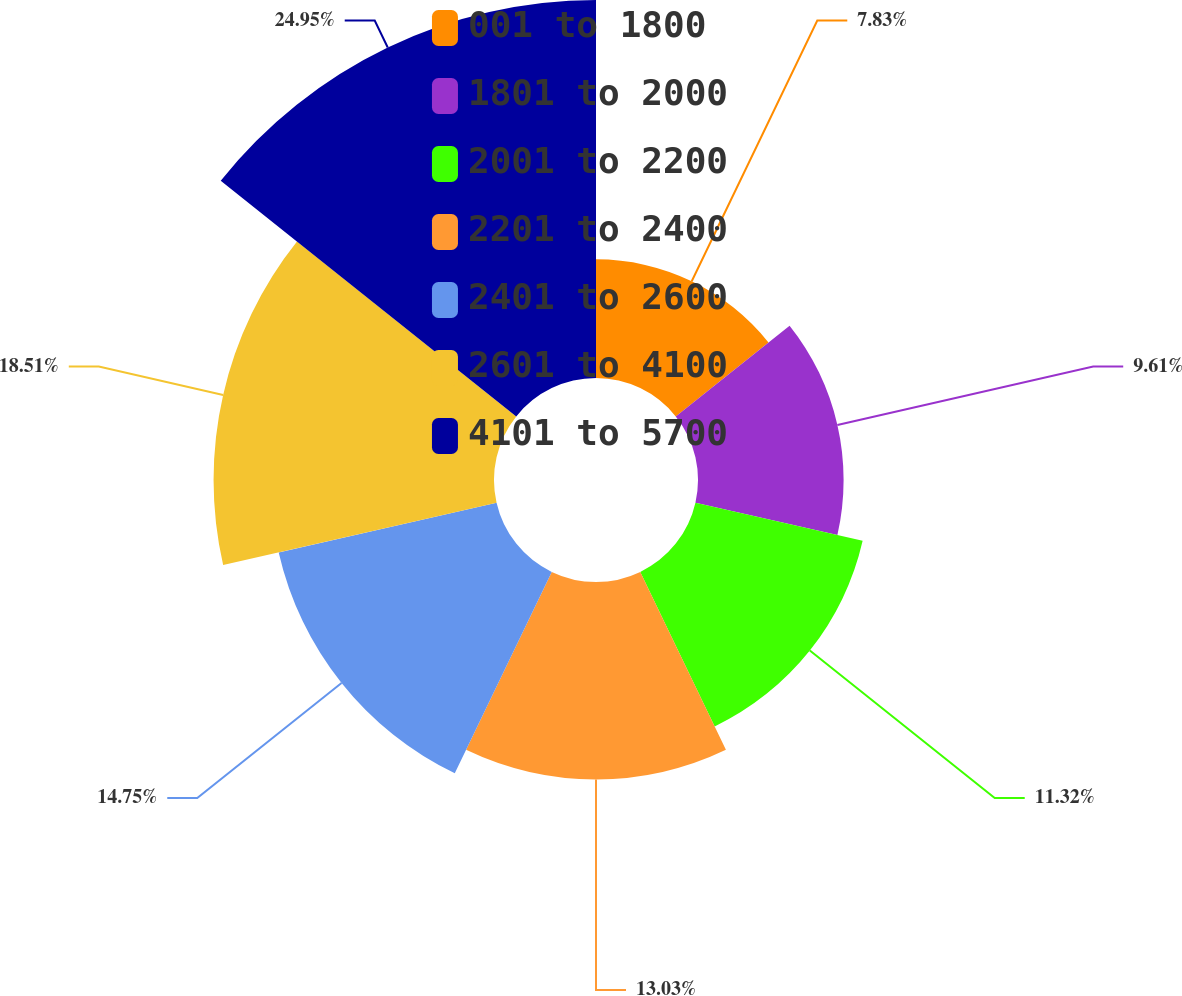Convert chart. <chart><loc_0><loc_0><loc_500><loc_500><pie_chart><fcel>001 to 1800<fcel>1801 to 2000<fcel>2001 to 2200<fcel>2201 to 2400<fcel>2401 to 2600<fcel>2601 to 4100<fcel>4101 to 5700<nl><fcel>7.83%<fcel>9.61%<fcel>11.32%<fcel>13.03%<fcel>14.75%<fcel>18.51%<fcel>24.95%<nl></chart> 